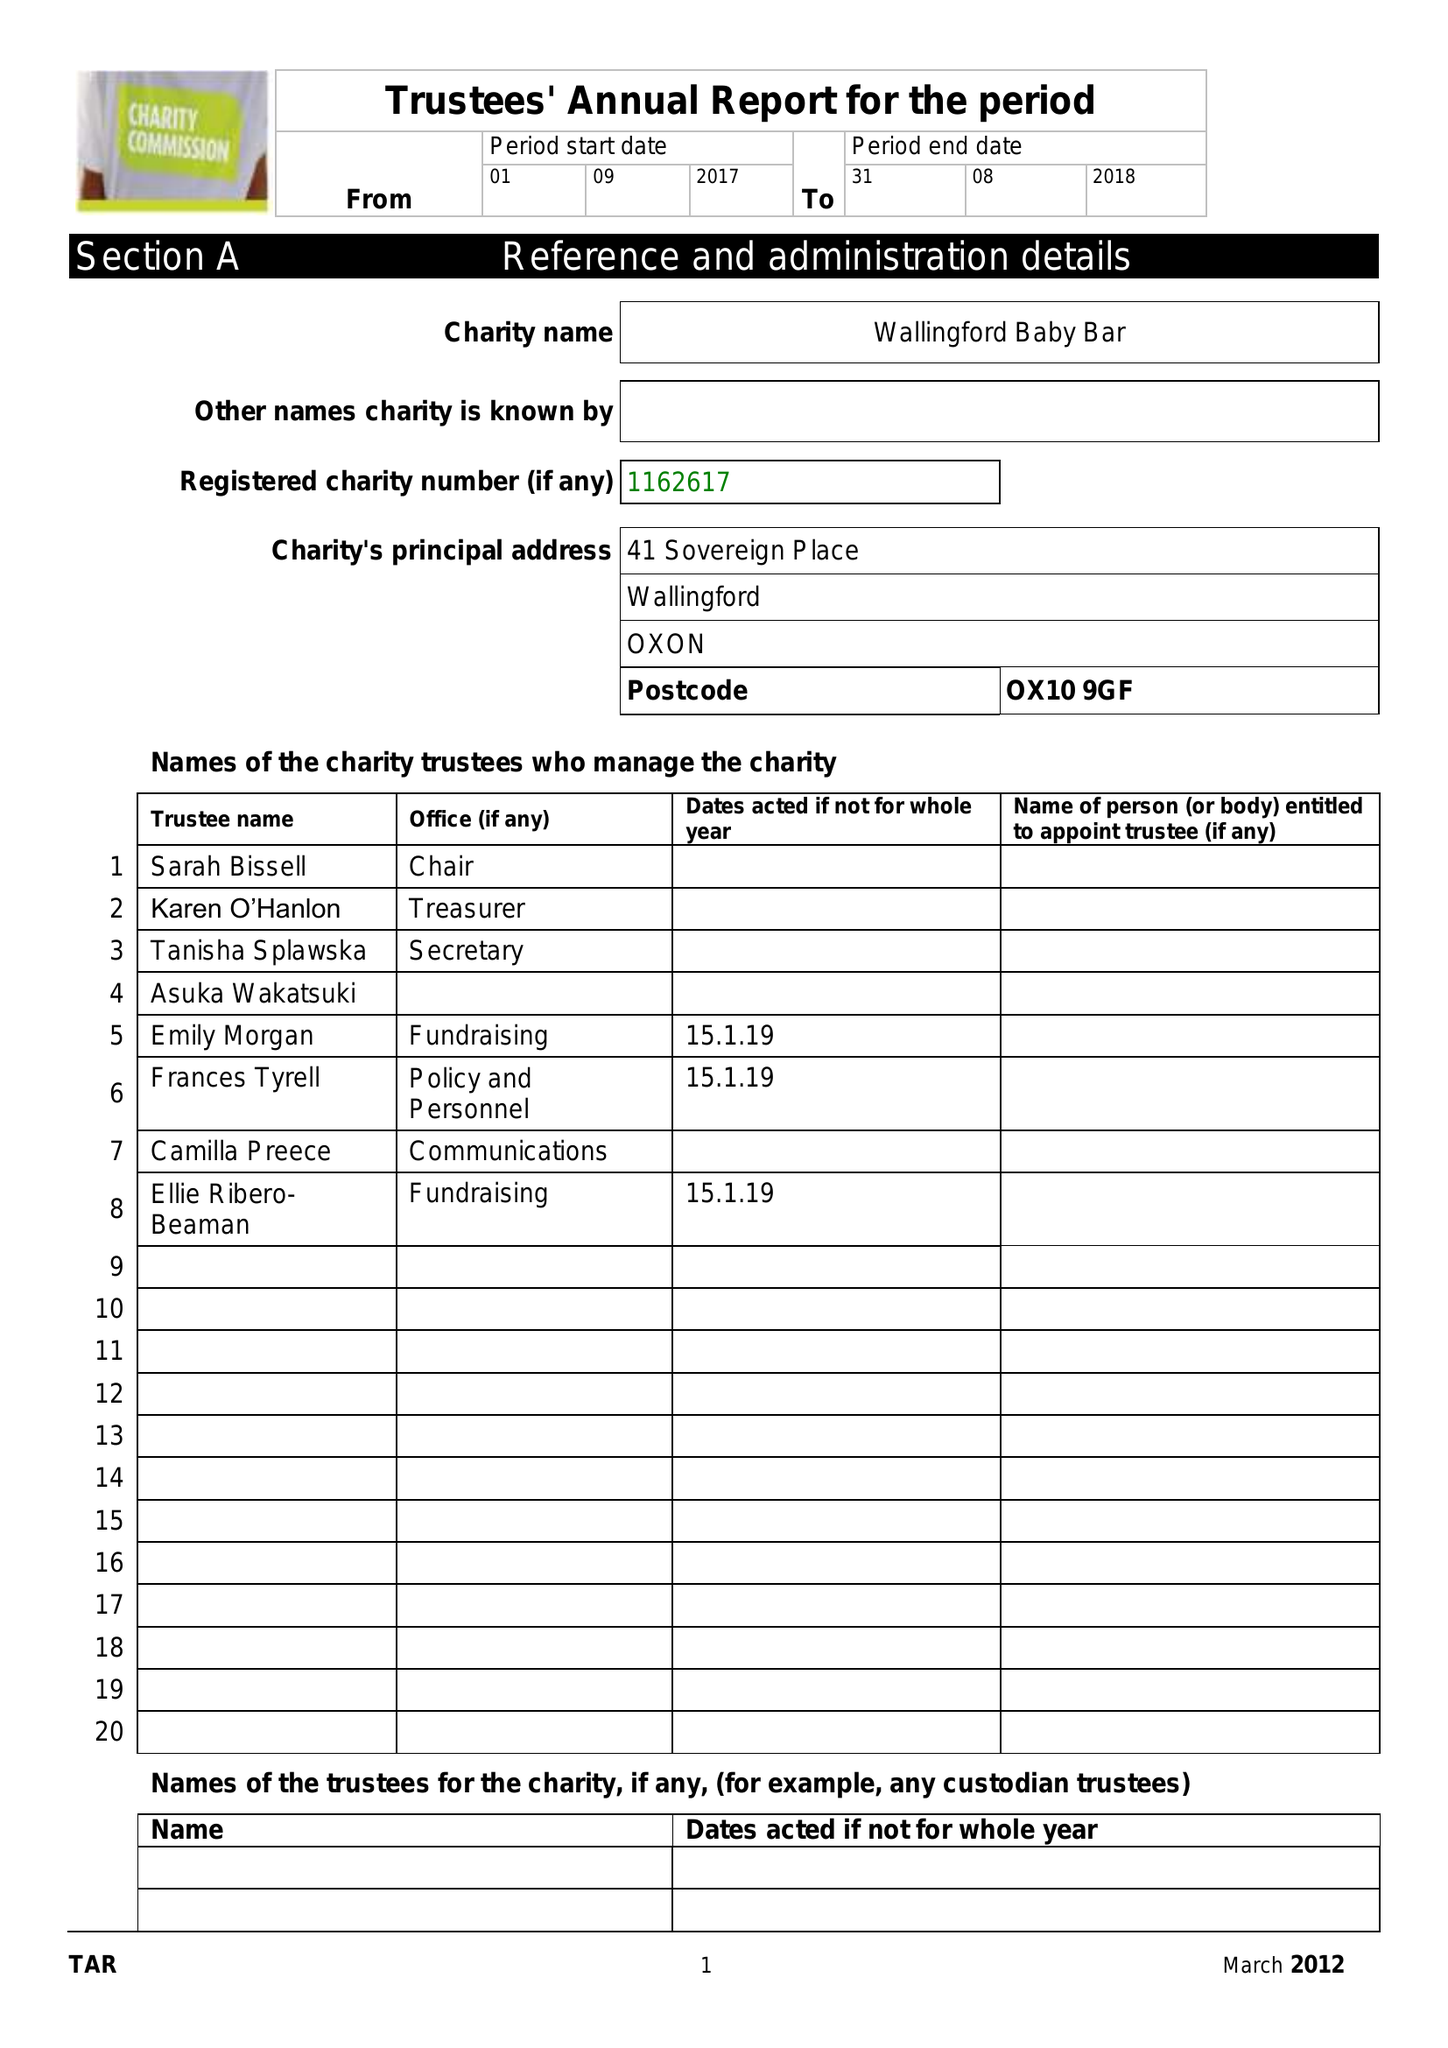What is the value for the income_annually_in_british_pounds?
Answer the question using a single word or phrase. 2370.00 